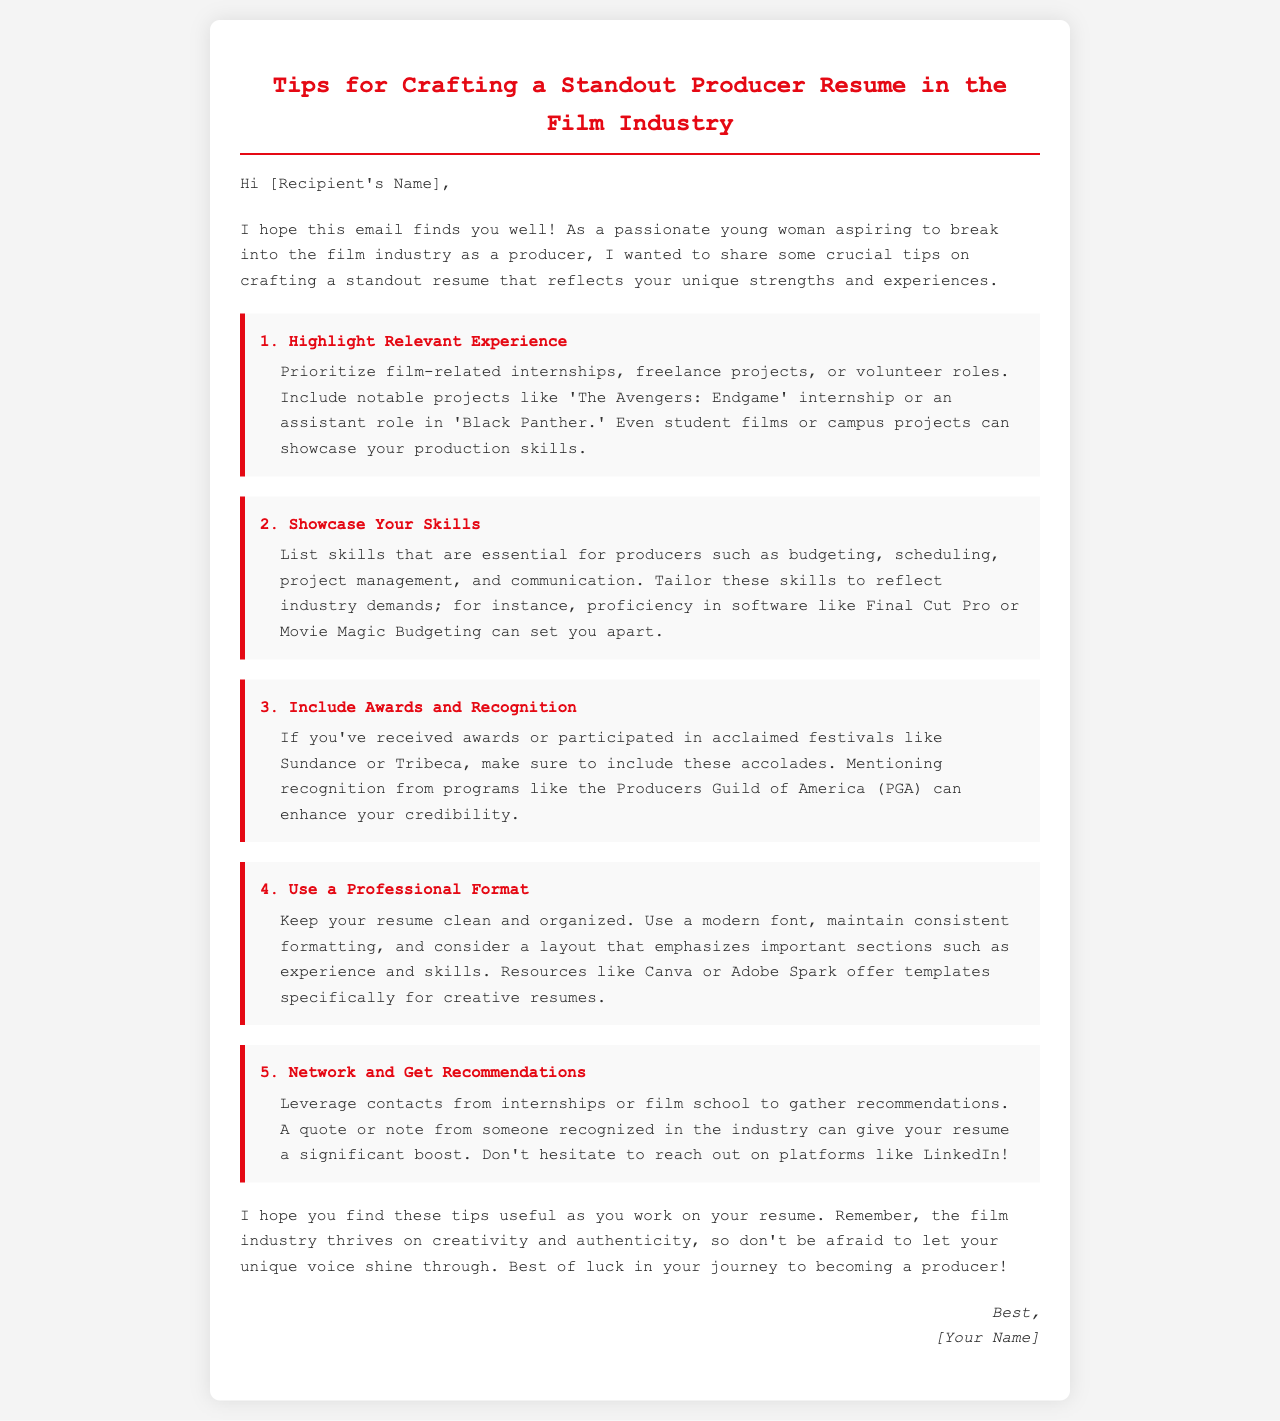What is the primary purpose of the email? The email aims to share tips on crafting a standout resume for aspiring producers in the film industry.
Answer: Tips for crafting a standout resume How many key tips are provided in the email? The email contains a total of five essential tips for creating a standout producer resume.
Answer: Five Which film is mentioned as an example of a notable project for internships? The email references 'The Avengers: Endgame' as a notable project for film-related internships.
Answer: The Avengers: Endgame What skill is suggested for inclusion under a producer's skillset? The email recommends including skills like budgeting, scheduling, and project management in a producer's resume.
Answer: Budgeting What recognitions should be mentioned to enhance credibility? The email suggests mentioning awards or participation in acclaimed festivals such as Sundance and Tribeca to boost credibility.
Answer: Sundance and Tribeca What should the format of the resume be described as? The email emphasizes that the resume should be clean and organized while using a modern font.
Answer: Clean and organized Where can one find templates for creative resumes? The email mentions resources like Canva or Adobe Spark for templates specifically tailored for creative resumes.
Answer: Canva or Adobe Spark What is encouraged in the email for showcasing unique qualities? The email encourages letting your unique voice shine through in your resume as a way to reflect creativity and authenticity.
Answer: Unique voice What is the closing expression in the email? The closing expression in the email conveys best wishes for the recipient's journey to become a producer.
Answer: Best of luck 